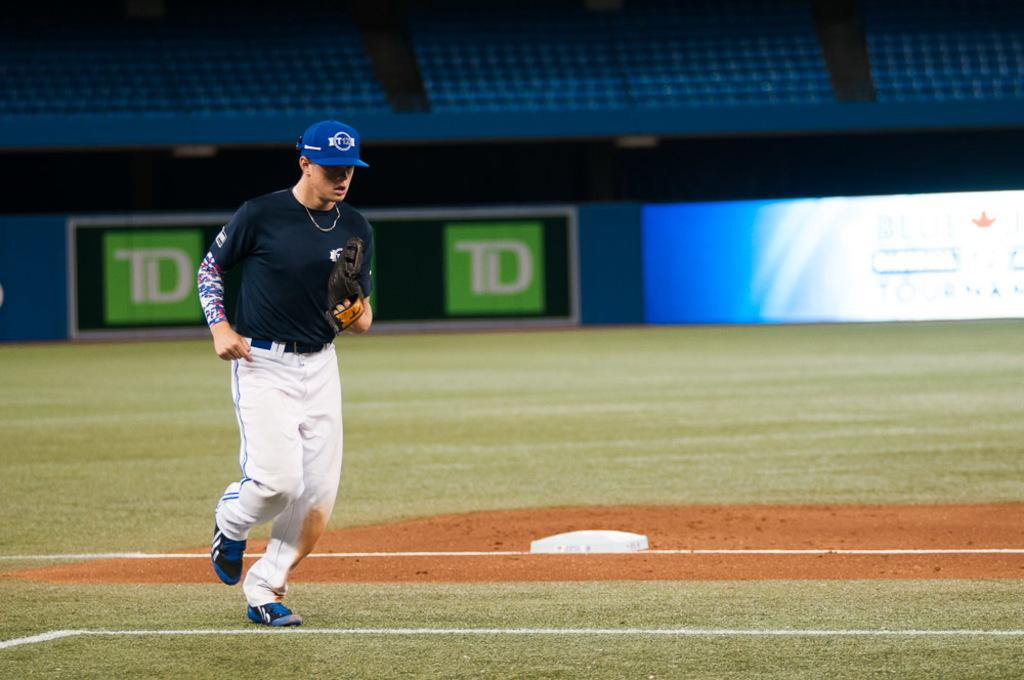<image>
Present a compact description of the photo's key features. A TD logo can be seen on a baseball field. 